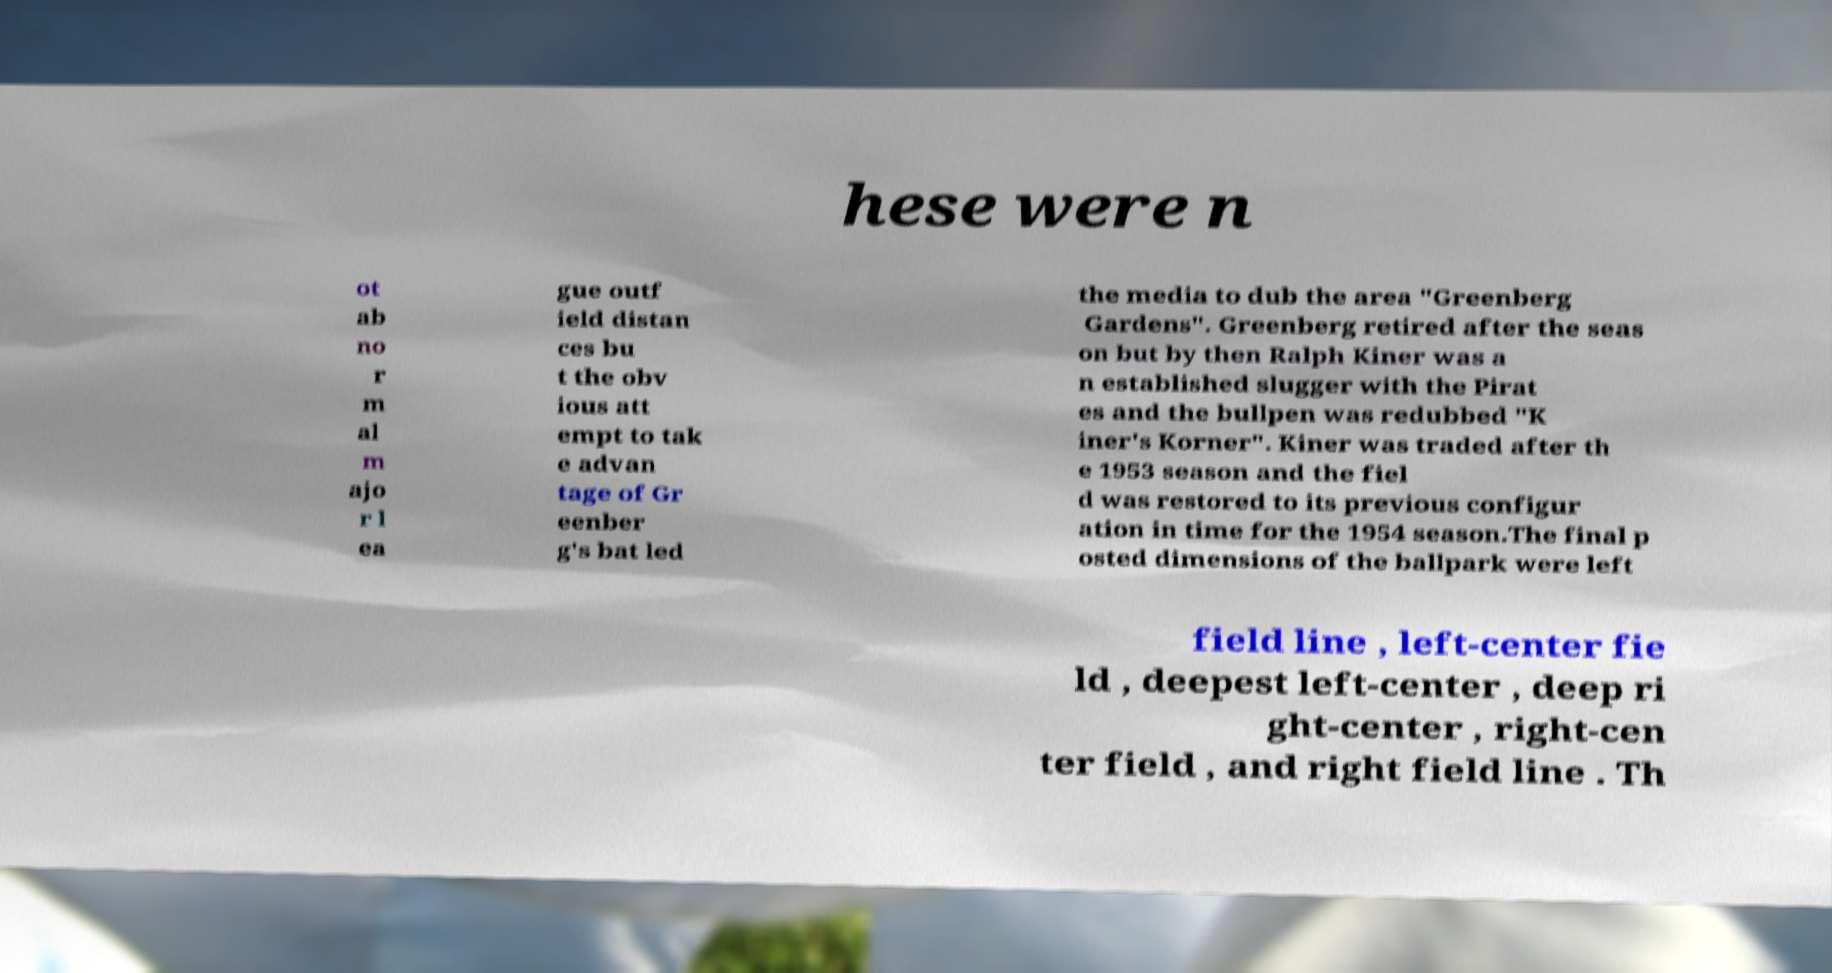Can you read and provide the text displayed in the image?This photo seems to have some interesting text. Can you extract and type it out for me? hese were n ot ab no r m al m ajo r l ea gue outf ield distan ces bu t the obv ious att empt to tak e advan tage of Gr eenber g's bat led the media to dub the area "Greenberg Gardens". Greenberg retired after the seas on but by then Ralph Kiner was a n established slugger with the Pirat es and the bullpen was redubbed "K iner's Korner". Kiner was traded after th e 1953 season and the fiel d was restored to its previous configur ation in time for the 1954 season.The final p osted dimensions of the ballpark were left field line , left-center fie ld , deepest left-center , deep ri ght-center , right-cen ter field , and right field line . Th 